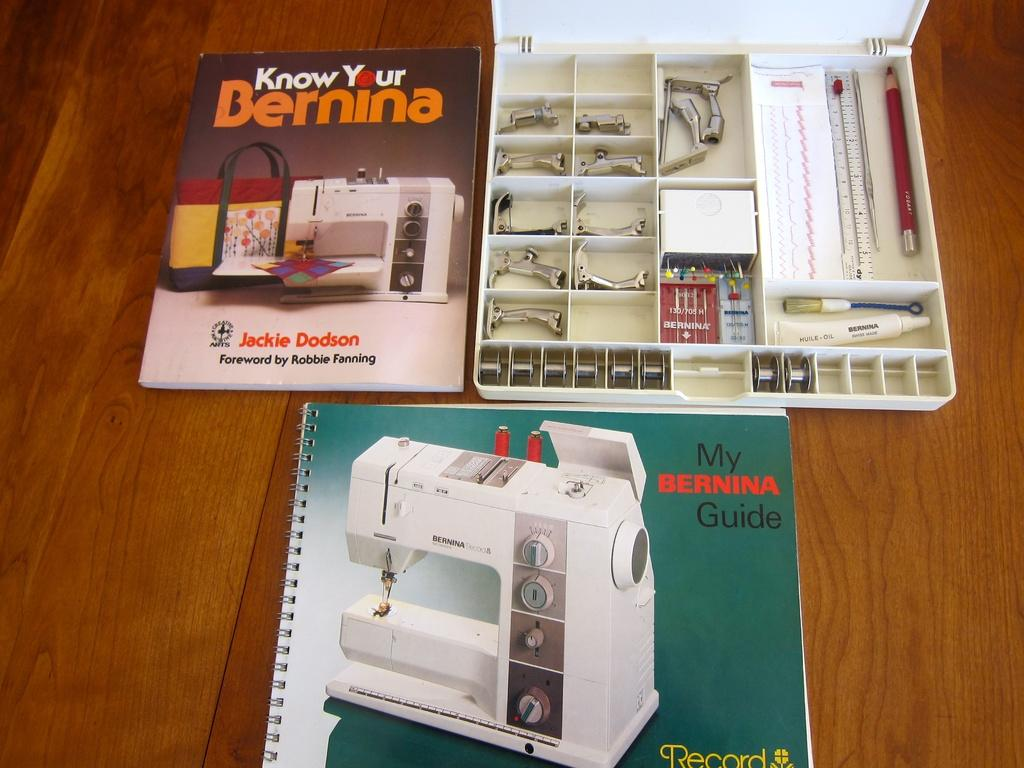How many books are visible in the image? There are two books in the image. What else is present on the table besides the books? There is a toolbox in the image. What is inside the toolbox? The toolbox contains tools. Where are the books and toolbox located? The books and toolbox are on top of a table. What type of clouds can be seen in the image? There are no clouds present in the image; it features books and a toolbox on a table. 